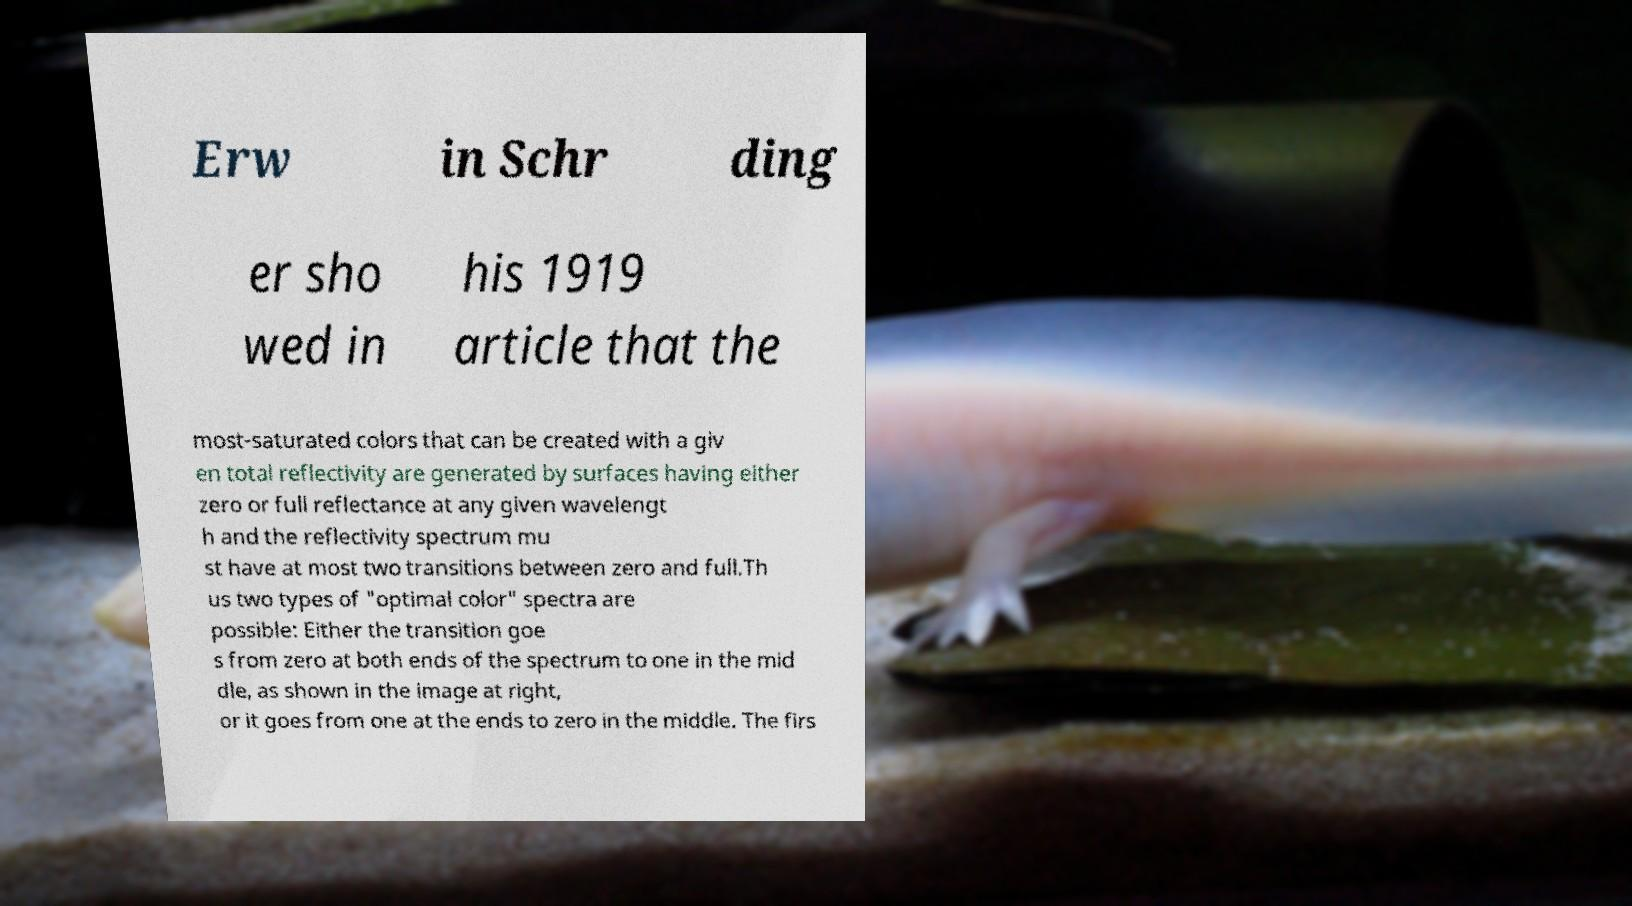Please read and relay the text visible in this image. What does it say? Erw in Schr ding er sho wed in his 1919 article that the most-saturated colors that can be created with a giv en total reflectivity are generated by surfaces having either zero or full reflectance at any given wavelengt h and the reflectivity spectrum mu st have at most two transitions between zero and full.Th us two types of "optimal color" spectra are possible: Either the transition goe s from zero at both ends of the spectrum to one in the mid dle, as shown in the image at right, or it goes from one at the ends to zero in the middle. The firs 